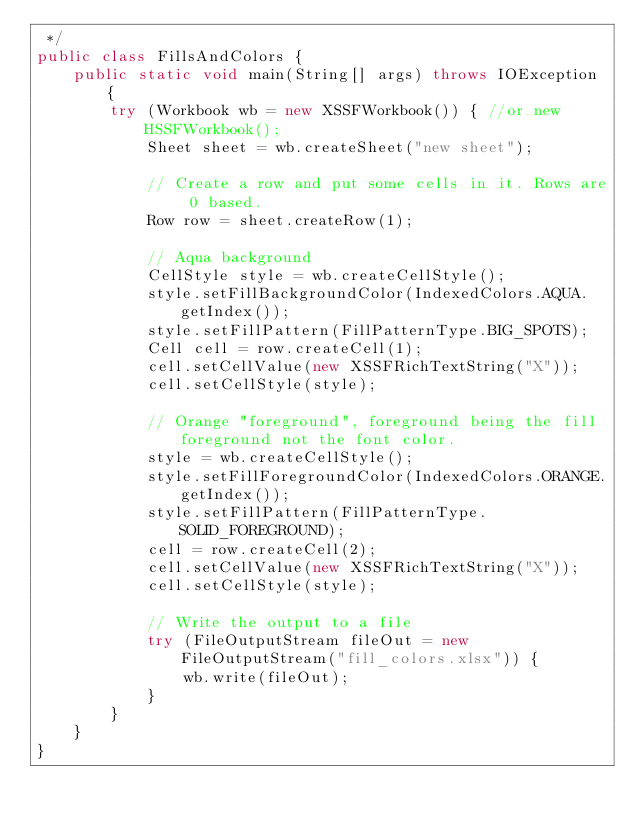Convert code to text. <code><loc_0><loc_0><loc_500><loc_500><_Java_> */
public class FillsAndColors {
    public static void main(String[] args) throws IOException {
        try (Workbook wb = new XSSFWorkbook()) { //or new HSSFWorkbook();
            Sheet sheet = wb.createSheet("new sheet");

            // Create a row and put some cells in it. Rows are 0 based.
            Row row = sheet.createRow(1);

            // Aqua background
            CellStyle style = wb.createCellStyle();
            style.setFillBackgroundColor(IndexedColors.AQUA.getIndex());
            style.setFillPattern(FillPatternType.BIG_SPOTS);
            Cell cell = row.createCell(1);
            cell.setCellValue(new XSSFRichTextString("X"));
            cell.setCellStyle(style);

            // Orange "foreground", foreground being the fill foreground not the font color.
            style = wb.createCellStyle();
            style.setFillForegroundColor(IndexedColors.ORANGE.getIndex());
            style.setFillPattern(FillPatternType.SOLID_FOREGROUND);
            cell = row.createCell(2);
            cell.setCellValue(new XSSFRichTextString("X"));
            cell.setCellStyle(style);

            // Write the output to a file
            try (FileOutputStream fileOut = new FileOutputStream("fill_colors.xlsx")) {
                wb.write(fileOut);
            }
        }
    }
}
</code> 